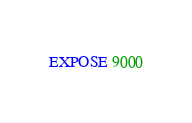<code> <loc_0><loc_0><loc_500><loc_500><_Dockerfile_>EXPOSE 9000
</code> 